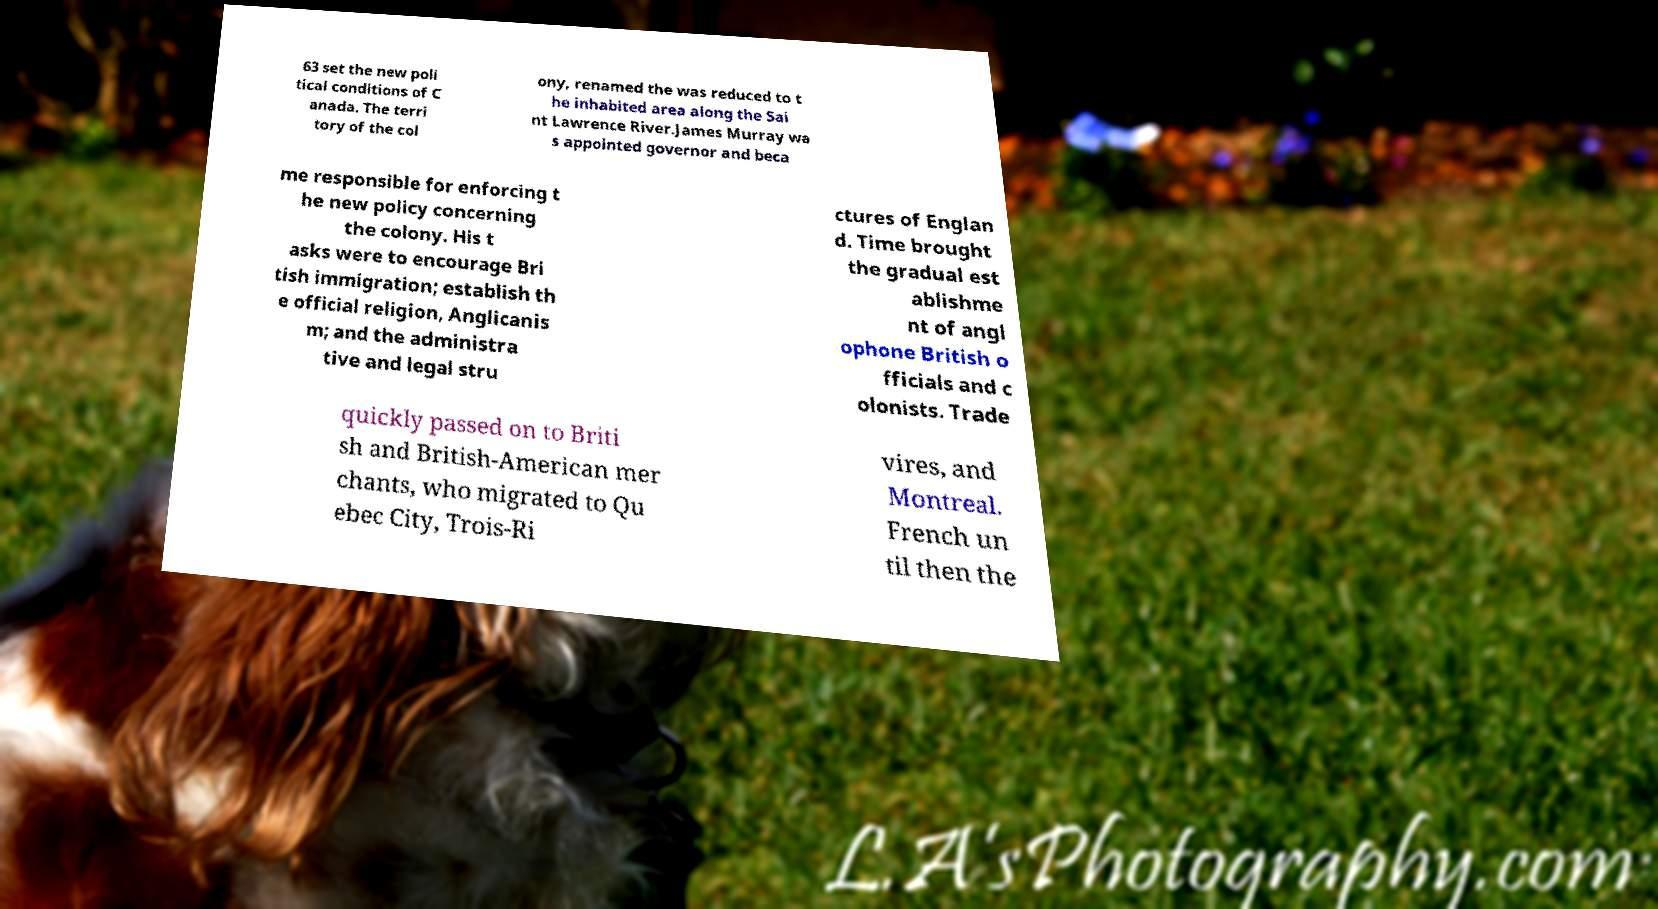Could you extract and type out the text from this image? 63 set the new poli tical conditions of C anada. The terri tory of the col ony, renamed the was reduced to t he inhabited area along the Sai nt Lawrence River.James Murray wa s appointed governor and beca me responsible for enforcing t he new policy concerning the colony. His t asks were to encourage Bri tish immigration; establish th e official religion, Anglicanis m; and the administra tive and legal stru ctures of Englan d. Time brought the gradual est ablishme nt of angl ophone British o fficials and c olonists. Trade quickly passed on to Briti sh and British-American mer chants, who migrated to Qu ebec City, Trois-Ri vires, and Montreal. French un til then the 